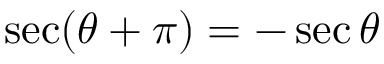<formula> <loc_0><loc_0><loc_500><loc_500>\sec ( \theta + \pi ) = - \sec \theta</formula> 